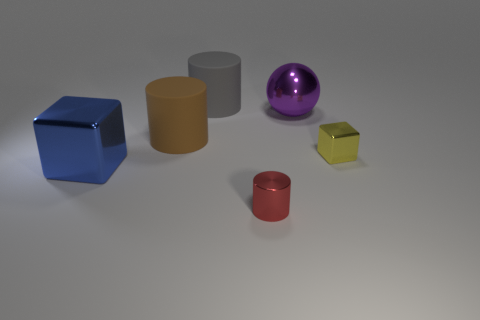How many other things are the same shape as the purple metal object?
Give a very brief answer. 0. Is the shape of the small object that is behind the large block the same as the large metal object that is in front of the metal ball?
Give a very brief answer. Yes. Is the number of brown rubber things that are in front of the large brown thing the same as the number of big metal blocks in front of the red cylinder?
Offer a terse response. Yes. The shiny object behind the small shiny object that is behind the small thing that is in front of the big blue cube is what shape?
Make the answer very short. Sphere. Is the material of the cube to the left of the small red cylinder the same as the cylinder that is behind the big brown rubber thing?
Give a very brief answer. No. There is a tiny metallic object that is behind the small red thing; what shape is it?
Offer a very short reply. Cube. Are there fewer large purple matte objects than brown cylinders?
Offer a very short reply. Yes. There is a large metallic object that is on the right side of the large gray rubber cylinder that is left of the red metallic object; are there any gray things that are in front of it?
Your response must be concise. No. How many matte objects are cyan balls or blue objects?
Offer a terse response. 0. Is the large ball the same color as the shiny cylinder?
Your answer should be very brief. No. 